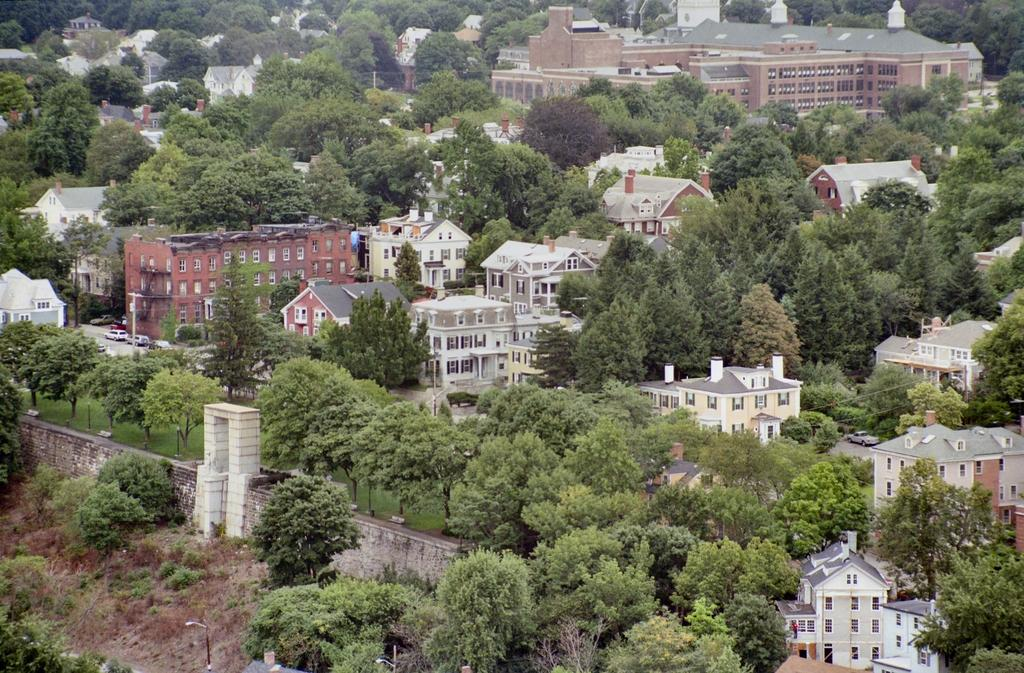What is located in the center of the image? There are buildings, windows, trees, grass, a pole, and plants in the center of the image. Can you describe the buildings in the image? The buildings in the image have windows and are surrounded by trees, grass, and plants. What is the pole used for in the image? The purpose of the pole in the image is not specified, but it could be used for signage or lighting. How many cans of soda are visible in the image? There are no cans of soda present in the image. Can you describe the snails crawling on the plants in the image? There are no snails visible in the image; only plants are present. 